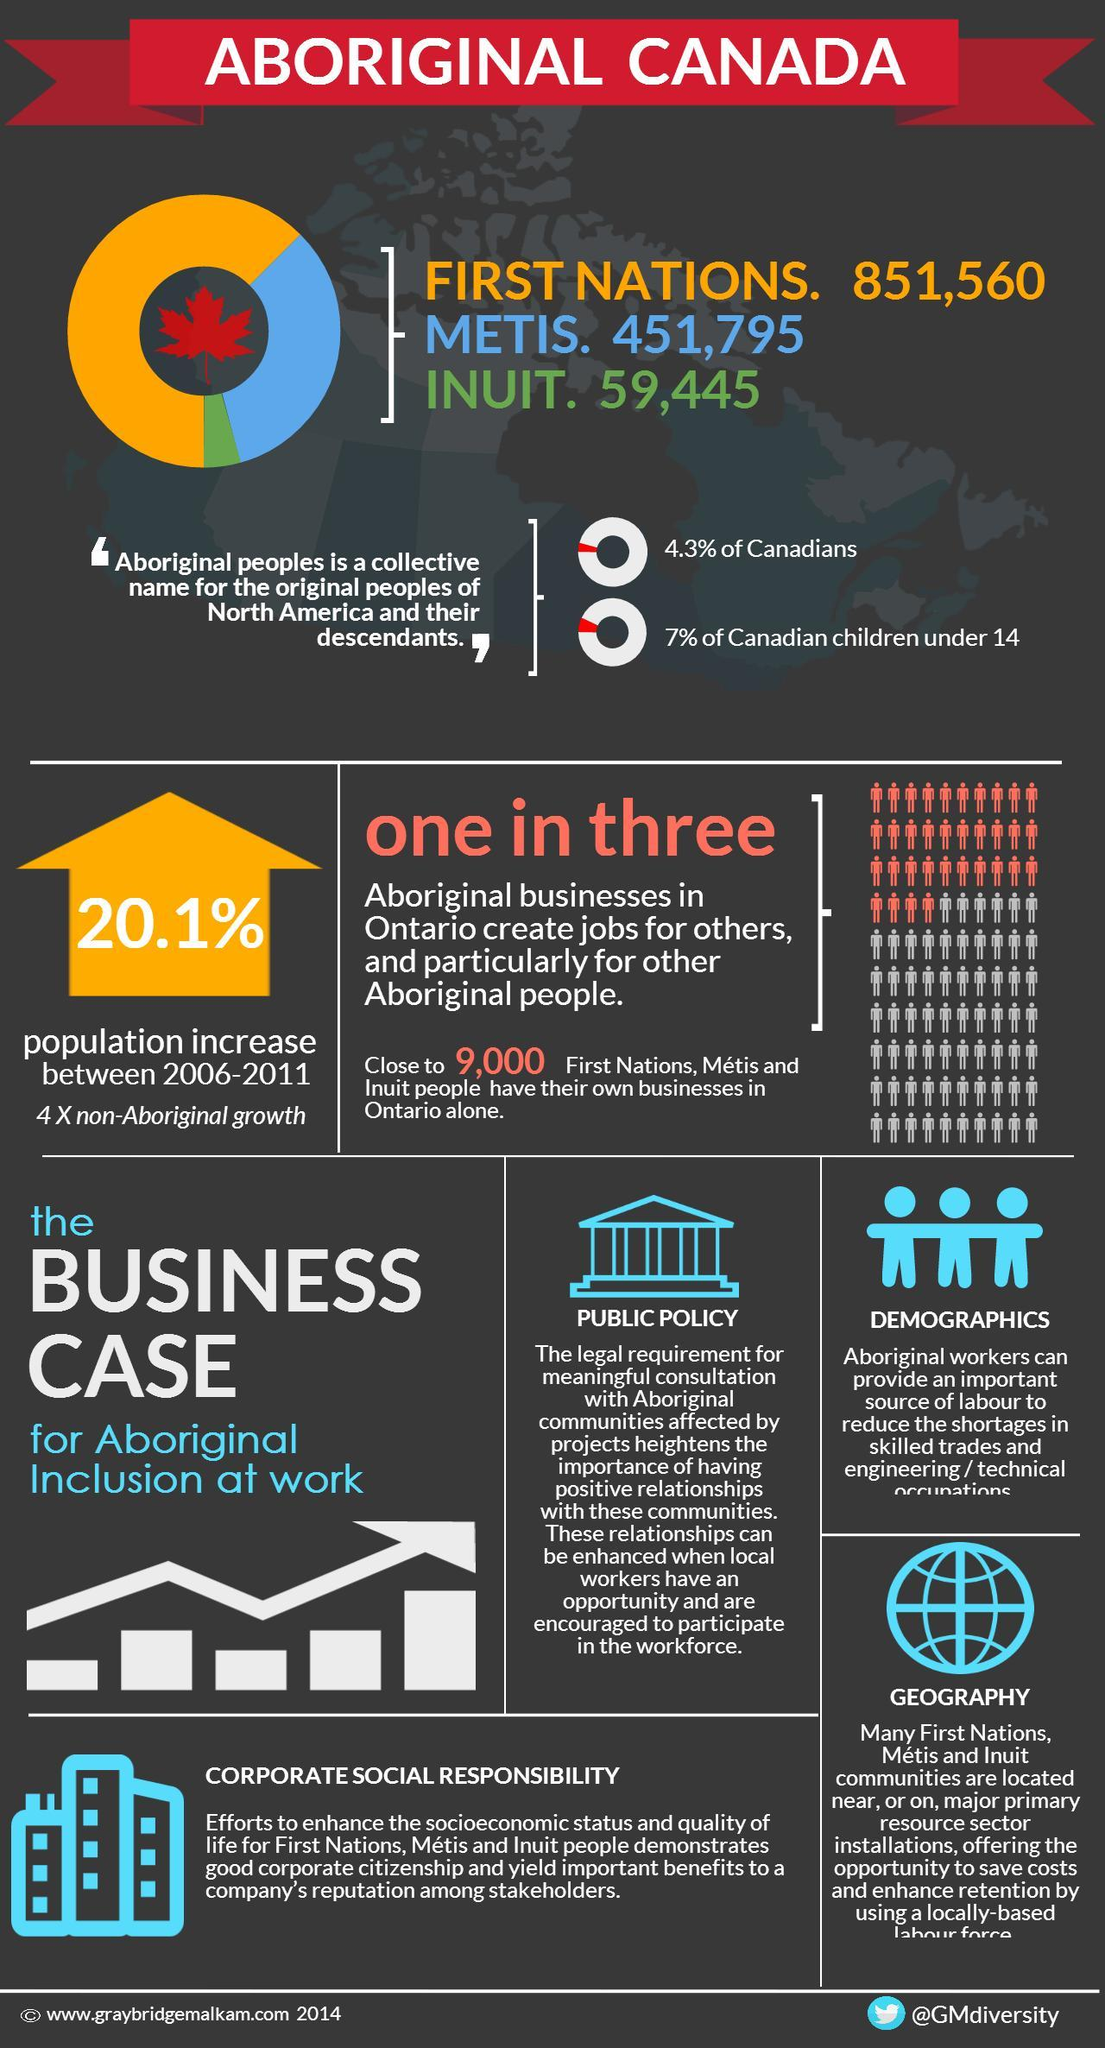What is the total number of Metis. and Inuit. people in Canada?
Answer the question with a short phrase. 511,240 